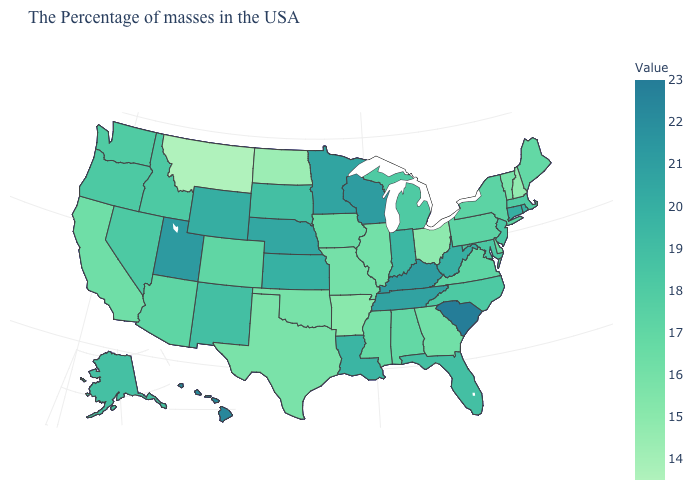Is the legend a continuous bar?
Keep it brief. Yes. Among the states that border Massachusetts , which have the lowest value?
Give a very brief answer. New Hampshire. Does Alabama have a higher value than North Dakota?
Short answer required. Yes. Which states have the highest value in the USA?
Keep it brief. South Carolina. Does South Carolina have the highest value in the USA?
Answer briefly. Yes. Is the legend a continuous bar?
Answer briefly. Yes. 